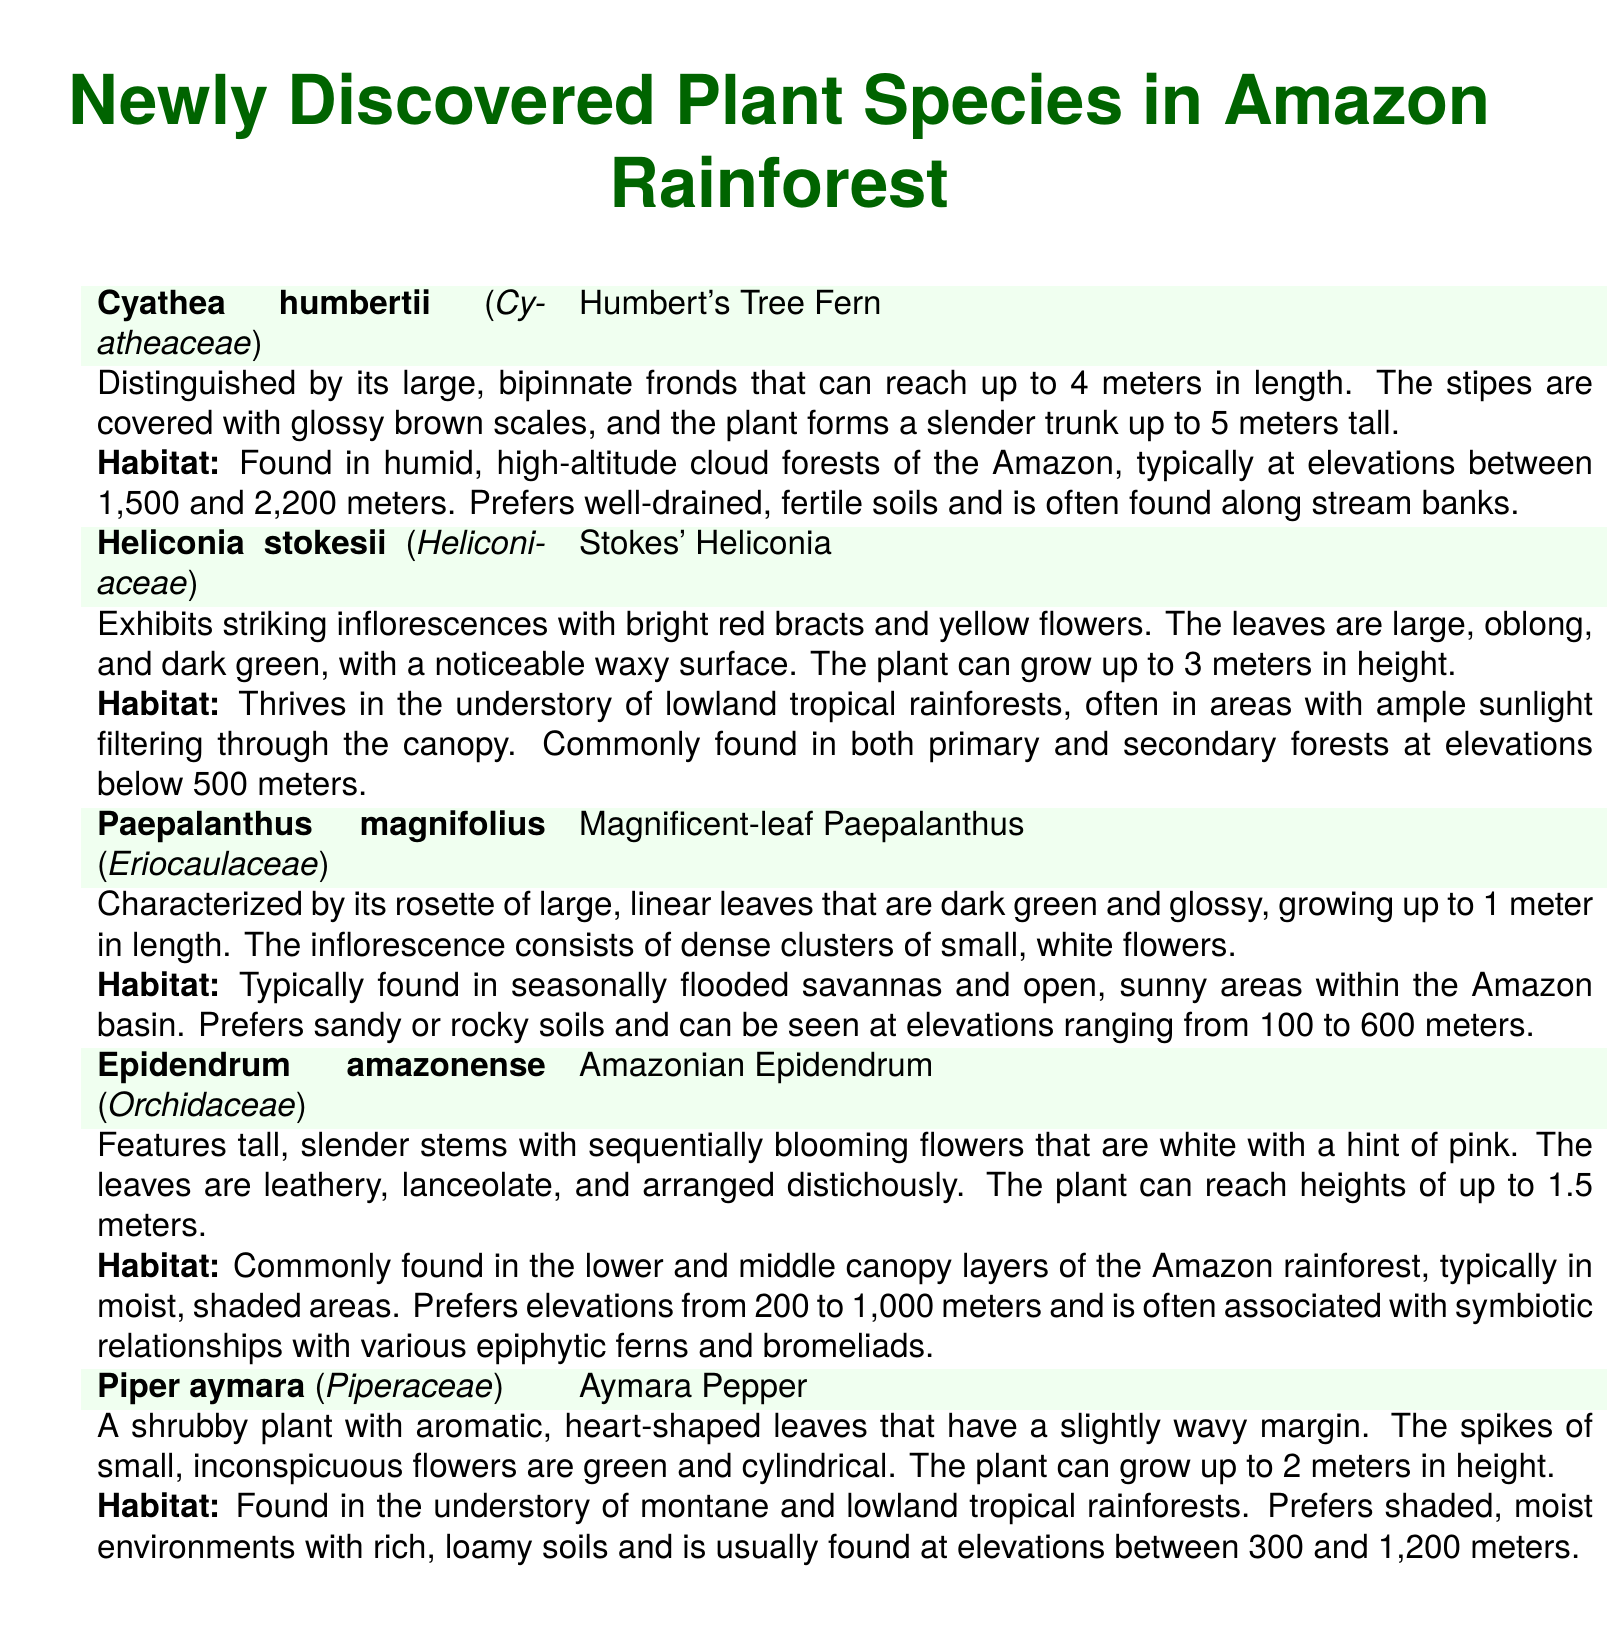What is the scientific name of Humbert's Tree Fern? The scientific name is specifically noted in the document under the common name.
Answer: Cyathea humbertii What family does Stokes' Heliconia belong to? The family is indicated along with the scientific name of the species.
Answer: Heliconiaceae How tall can the Magnificent-leaf Paepalanthus grow? The maximum height is specified in the morphological description of the species.
Answer: Up to 1 meter In what type of forest is the Amazonian Epidendrum commonly found? The habitat information specifies the typical forest environment for this species.
Answer: Lower and middle canopy layers What is the elevation range for Aymara Pepper? The elevation range is provided in the habitat information.
Answer: Between 300 and 1,200 meters How many species are mentioned in the document? Counting the listed species will give the total number of new discoveries presented.
Answer: Five Which species has large, bipinnate fronds? This characteristic is part of the morphological description for one of the species listed.
Answer: Cyathea humbertii What color are the bracts of Stokes' Heliconia? The color of the bracts is specifically mentioned in the morphological description.
Answer: Bright red Where are Paepalanthus magnifolius typically found? The habitat information specifies the environment in which this species thrives.
Answer: Seasonally flooded savannas 